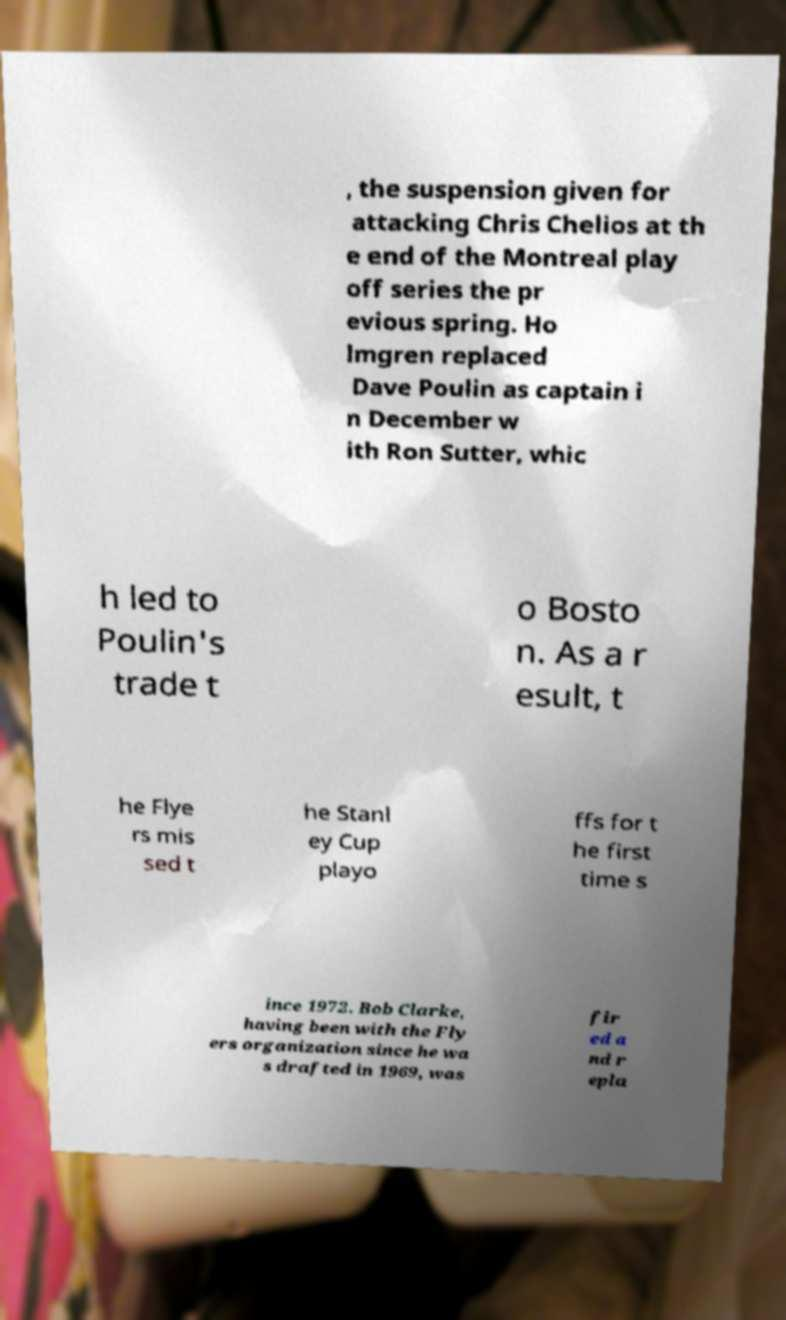Could you extract and type out the text from this image? , the suspension given for attacking Chris Chelios at th e end of the Montreal play off series the pr evious spring. Ho lmgren replaced Dave Poulin as captain i n December w ith Ron Sutter, whic h led to Poulin's trade t o Bosto n. As a r esult, t he Flye rs mis sed t he Stanl ey Cup playo ffs for t he first time s ince 1972. Bob Clarke, having been with the Fly ers organization since he wa s drafted in 1969, was fir ed a nd r epla 